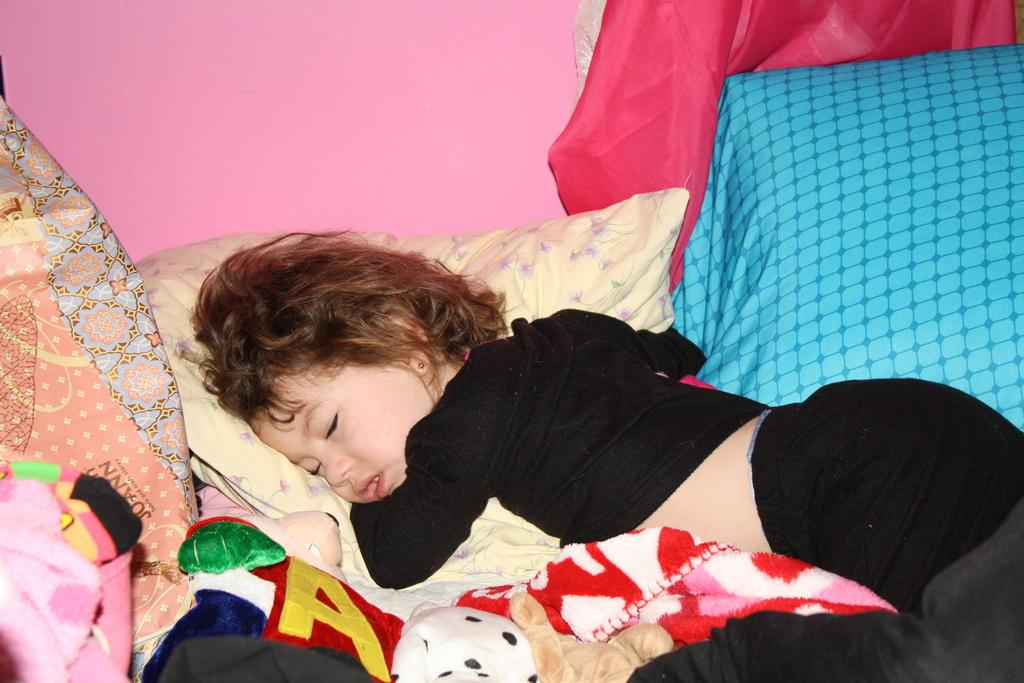What is the kid doing in the image? The kid is sleeping on the bed. What is on the bed with the kid? There are pillows on the bed. What can be seen in the background of the image? There is a wall in the background of the image. What is covering the kid at the bottom of the bed? There is a blanket at the bottom of the bed. What type of board is the kid using to fly in the image? There is no board or flight present in the image; the kid is sleeping on a bed. 